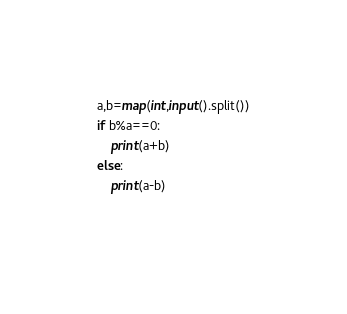<code> <loc_0><loc_0><loc_500><loc_500><_Python_>a,b=map(int,input().split())
if b%a==0:
    print(a+b)
else:
    print(a-b)
    </code> 